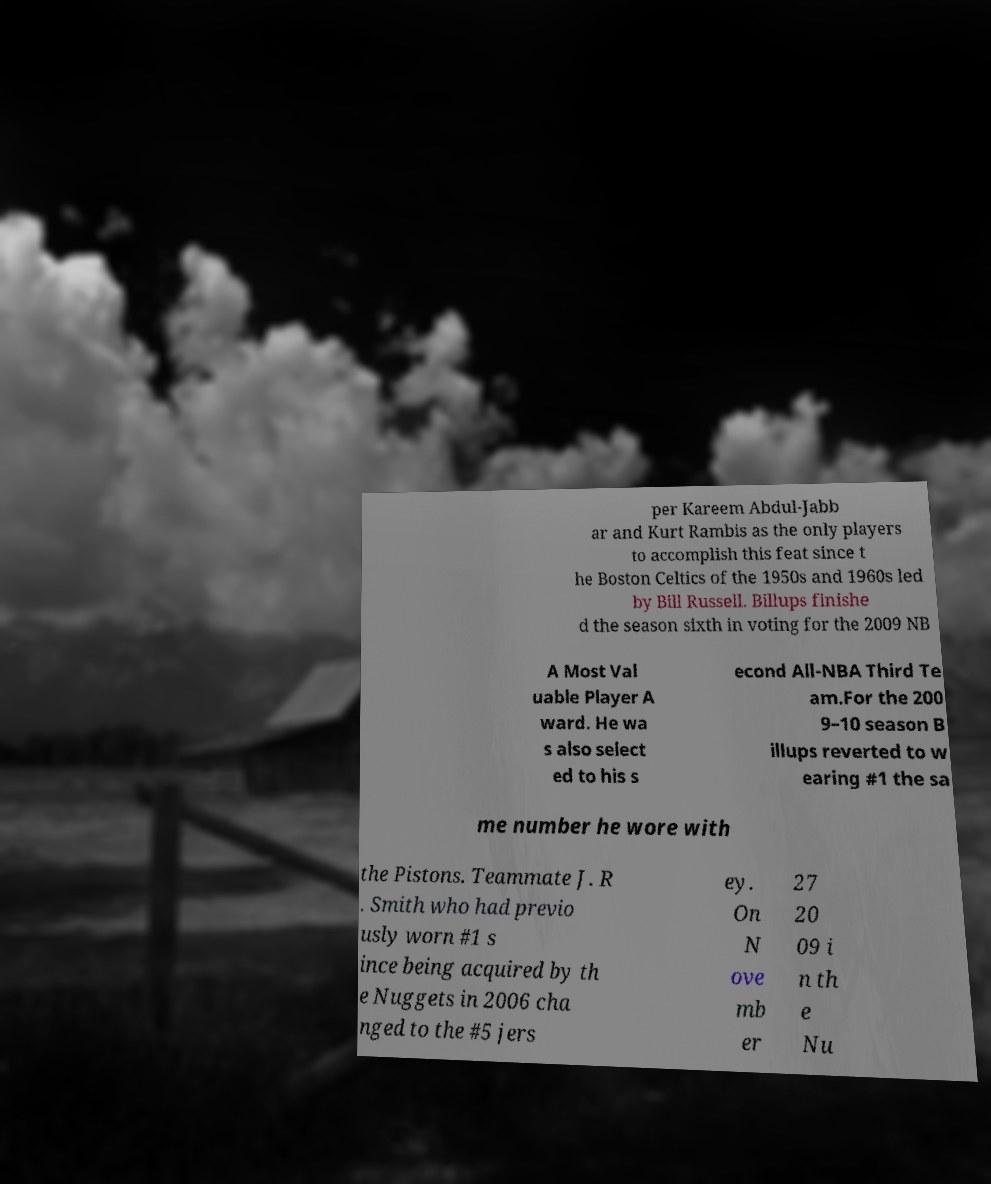Please read and relay the text visible in this image. What does it say? per Kareem Abdul-Jabb ar and Kurt Rambis as the only players to accomplish this feat since t he Boston Celtics of the 1950s and 1960s led by Bill Russell. Billups finishe d the season sixth in voting for the 2009 NB A Most Val uable Player A ward. He wa s also select ed to his s econd All-NBA Third Te am.For the 200 9–10 season B illups reverted to w earing #1 the sa me number he wore with the Pistons. Teammate J. R . Smith who had previo usly worn #1 s ince being acquired by th e Nuggets in 2006 cha nged to the #5 jers ey. On N ove mb er 27 20 09 i n th e Nu 